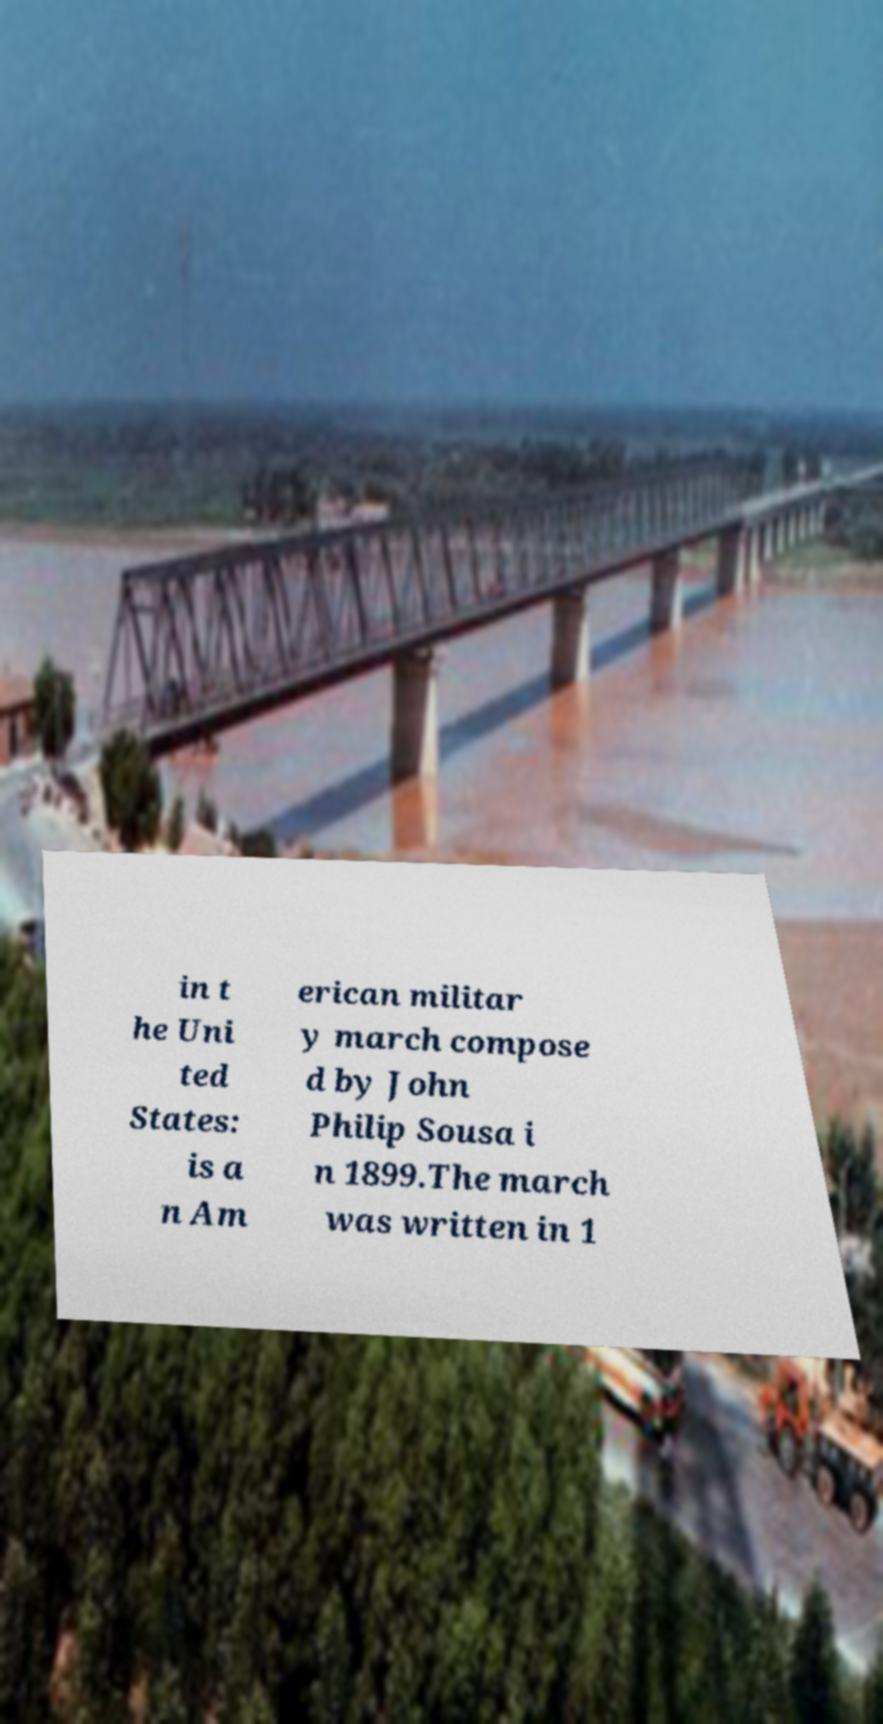Please read and relay the text visible in this image. What does it say? in t he Uni ted States: is a n Am erican militar y march compose d by John Philip Sousa i n 1899.The march was written in 1 